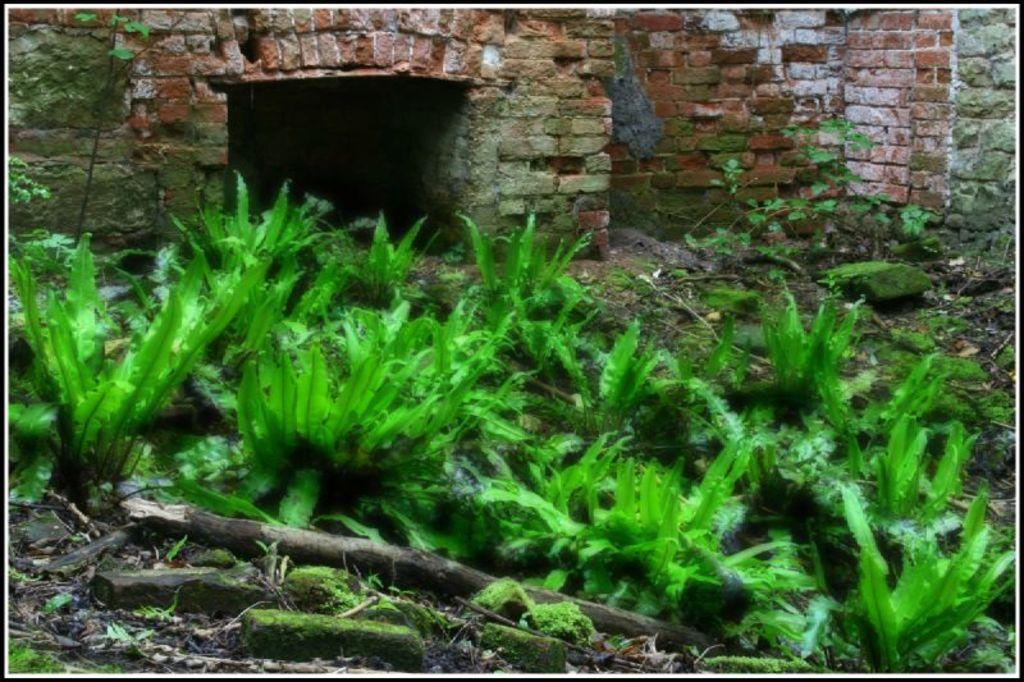What type of structure is visible in the image? There is a brick wall in the image. What is in front of the brick wall? There are plants in front of the wall. What type of terrain is visible in the image? There is mud visible in the image. What type of car can be seen driving through the brick wall in the image? There is no car present in the image, and the brick wall is not being driven through. 